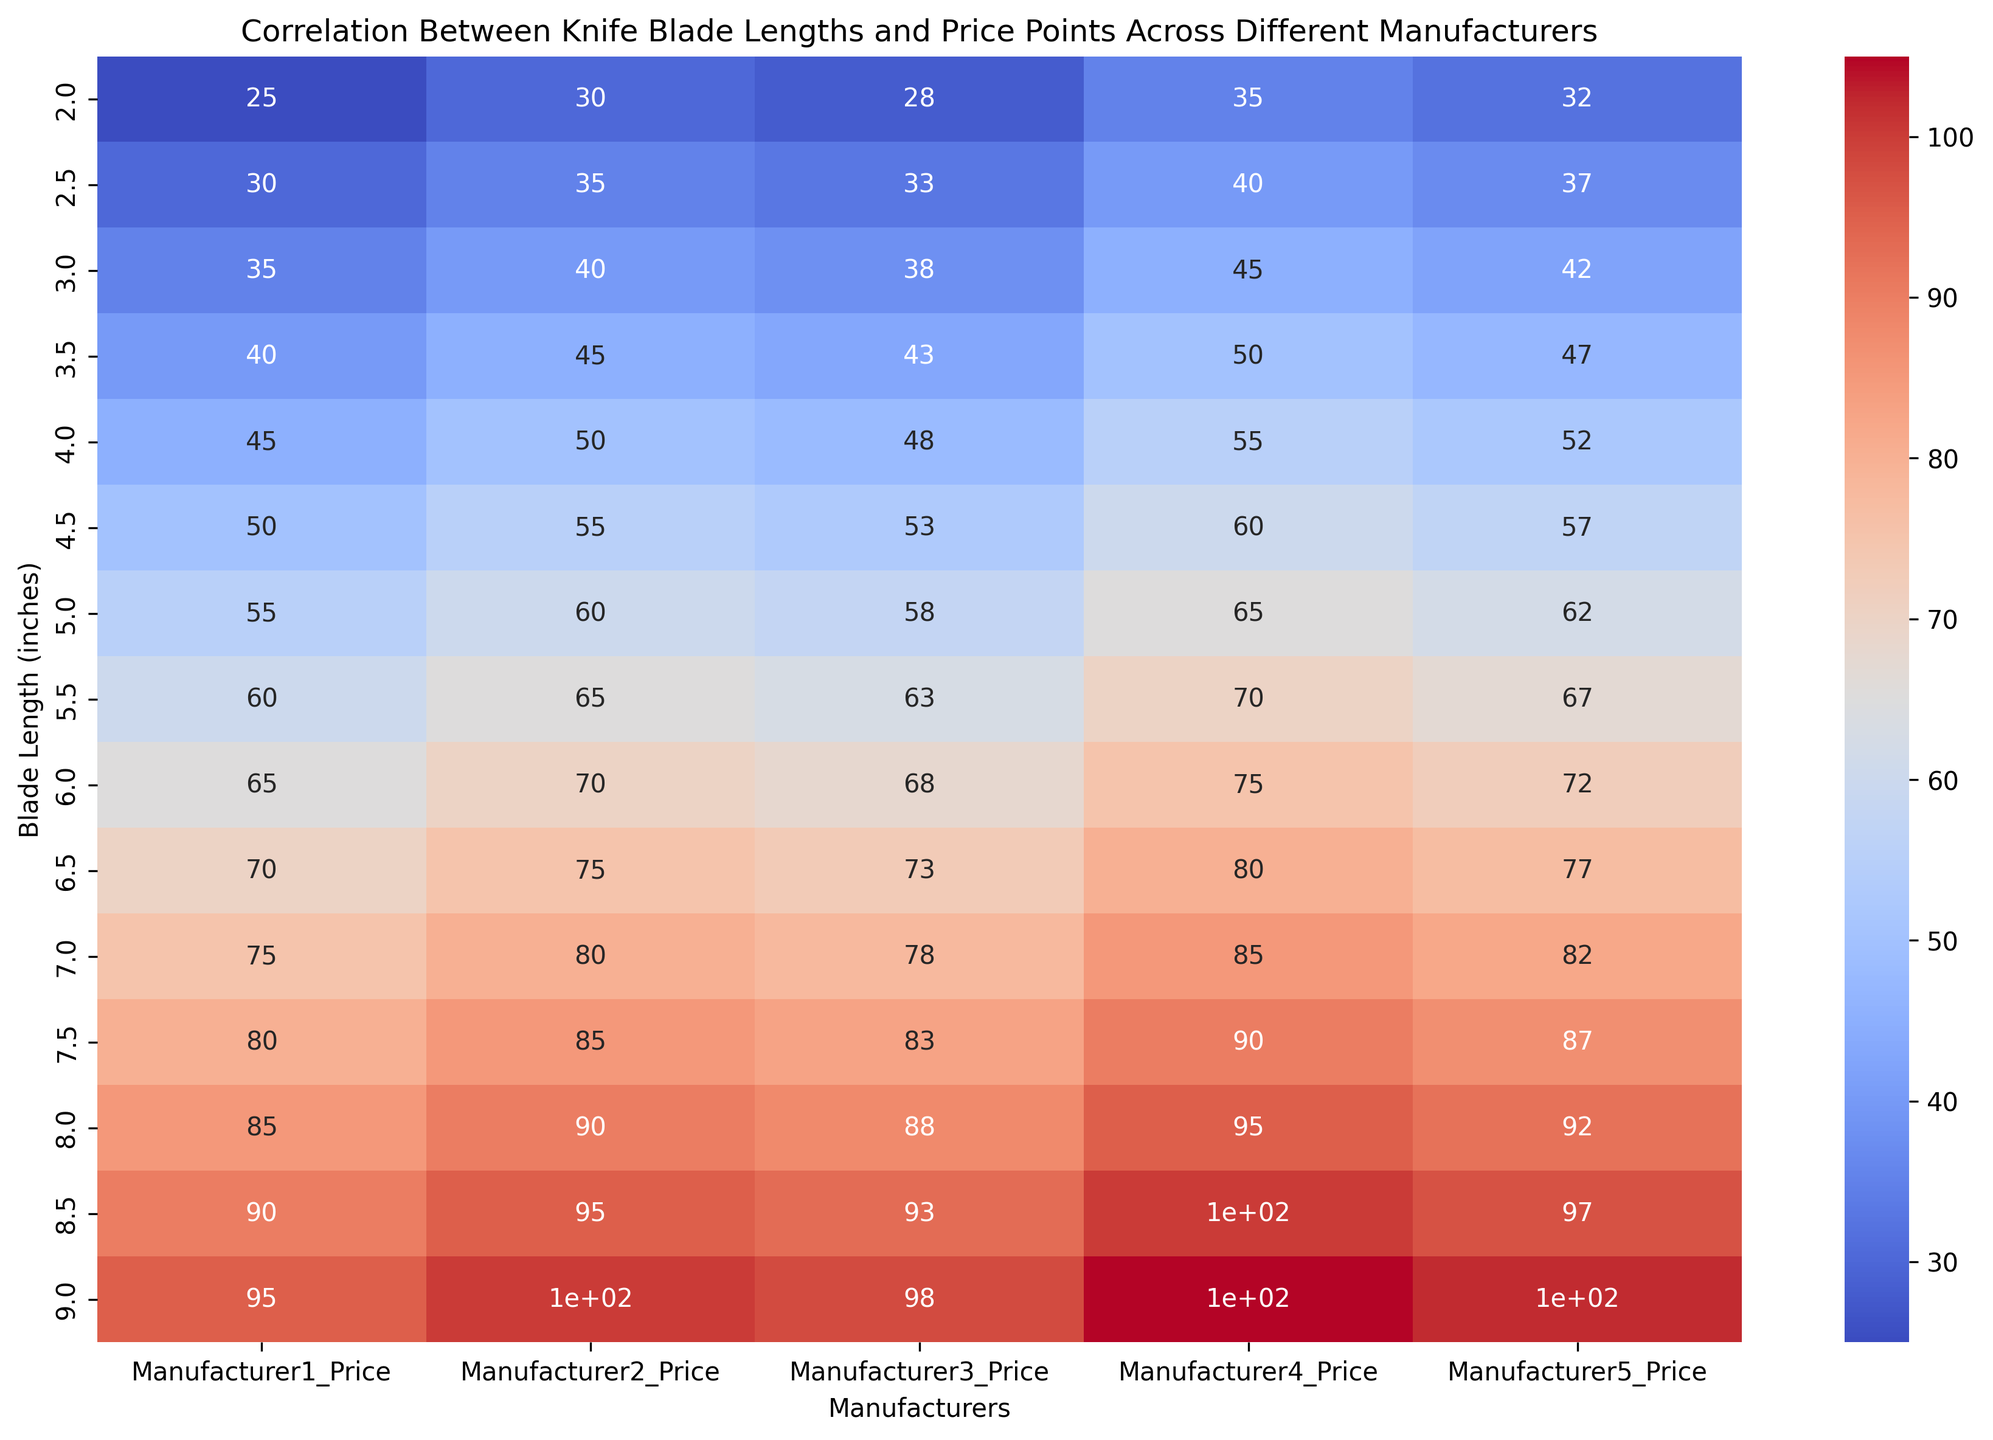Which Manufacturer has the highest price for the longest blade length (9.0 inches)? Look at the cell corresponding to Blade Length 9.0 inches for each manufacturer and identify the highest value.
Answer: Manufacturer4 Comparing Manufacturer1 and Manufacturer5, which one has more consistent price increases across different blade lengths? Examine the price values across different blade lengths for both manufacturers and note how steadily they increase. Manufacturer1 shows more consistent increments (prices increase by 5 for each increment in length), while Manufacturer5 does not.
Answer: Manufacturer1 At 5.0 inches blade length, which manufacturer has the lowest price point? Look at the row corresponding to Blade Length 5.0 inches and compare the price points for all manufacturers. Identify the lowest value.
Answer: Manufacturer1 What is the average price of a 6.5-inch blade across all manufacturers? Sum the prices for all manufacturers for the 6.5-inch blade length and divide by the number of manufacturers (70 + 75 + 73 + 80 + 77) / 5 = 75.
Answer: 75 Is there any manufacturer whose prices always increase incrementally by the same amount with increasing blade length? Check the price increments for each manufacturer with increasing blade length. Manufacturer1 has prices increasing consistently by 5 with each 0.5-inch increment.
Answer: Yes, Manufacturer1 Which manufacturer has the widest range in prices from the shortest blade length to the longest blade length? Calculate the price range (difference between the highest and lowest price) for each manufacturer. Manufacturer5: 97 - 32 = 65, Manufacturer4: 105 - 35 = 70, Manufacturer3: 98 - 28 = 70, Manufacturer2: 95 - 30 = 65, Manufacturer1: 95 - 25 = 70.
Answer: Manufacturers 3 and 4 (tied) Does Manufacturer3 have any outlier prices, or are they consistent with other manufacturers at comparable blade lengths? Compare the prices of Manufacturer3 across all blade lengths with other manufacturers at the same lengths. Manufacturer3's prices are consistently between those of Manufacturer1 and Manufacturer2, indicating no outlier prices.
Answer: Consistent Which manufacturer has comparatively higher prices than others starting from the 3.0-inch blade length onwards? Compare price points for each manufacturer starting from the 3.0-inch blade length and look for consistently higher values. Manufacturer4 has higher prices from 3.0 inches onwards.
Answer: Manufacturer4 What is the combined price for a 4.0-inch blade from Manufacturer1 and a 7.0-inch blade from Manufacturer2? Add the price of the 4.0-inch blade from Manufacturer1 and the 7.0-inch blade from Manufacturer2 (45 + 80).
Answer: 125 For the 8.0-inch blade length, what is the price difference between the manufacturer with the highest price and the manufacturer with the lowest price? Compare the prices for the 8.0-inch blade length and find the differences between the highest and lowest prices (95 - 85).
Answer: 10 